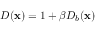Convert formula to latex. <formula><loc_0><loc_0><loc_500><loc_500>D ( x ) = 1 + \beta D _ { b } ( x )</formula> 